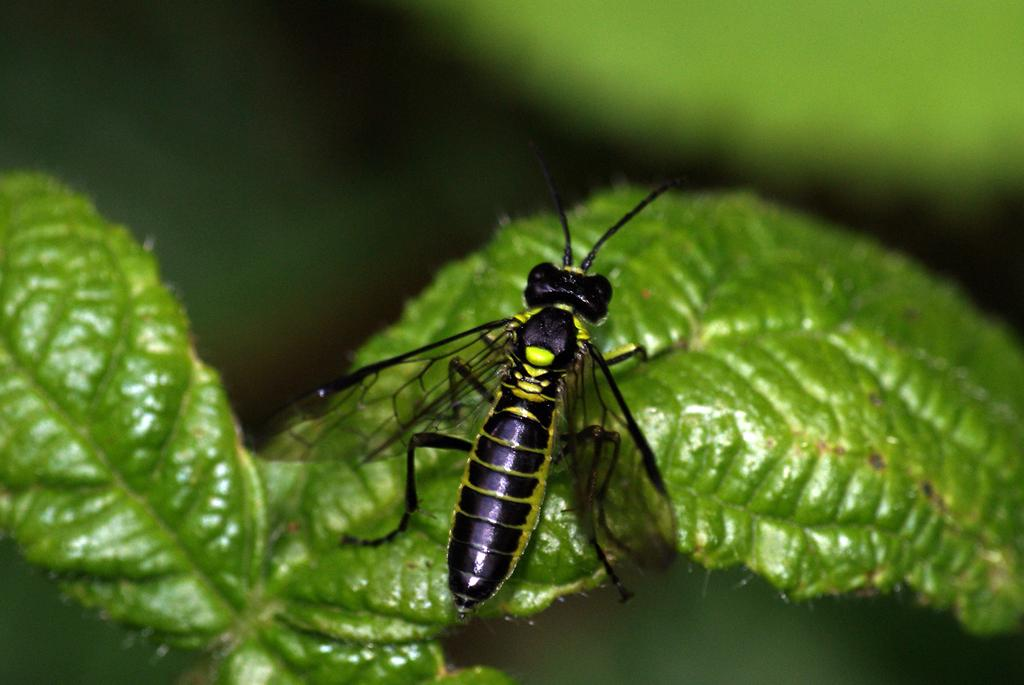What is the main subject of the image? The main subject of the image is a black fly. Where is the fly located in the image? The fly is on a leaf. Can you describe the background of the image? The background of the image is blurred. What type of agreement is being discussed in the image? There is no discussion or agreement present in the image; it features a black fly on a leaf with a blurred background. 